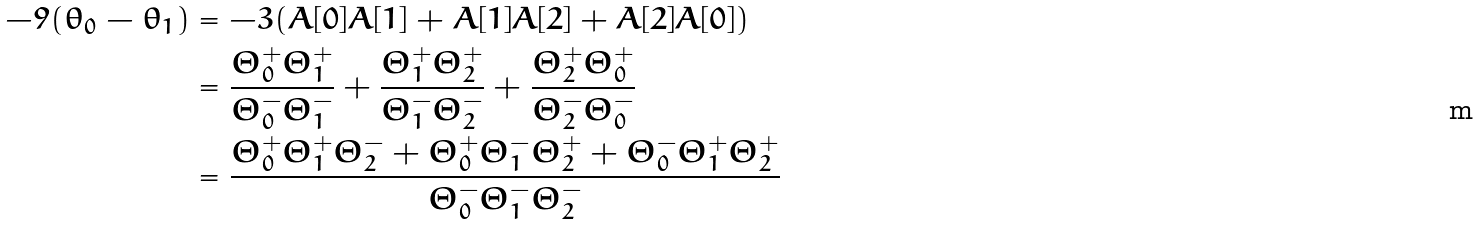<formula> <loc_0><loc_0><loc_500><loc_500>- 9 ( \theta _ { 0 } - \theta _ { 1 } ) & = - 3 ( A [ 0 ] A [ 1 ] + A [ 1 ] A [ 2 ] + A [ 2 ] A [ 0 ] ) \\ & = \frac { \Theta ^ { + } _ { 0 } \Theta ^ { + } _ { 1 } } { \Theta ^ { - } _ { 0 } \Theta ^ { - } _ { 1 } } + \frac { \Theta ^ { + } _ { 1 } \Theta ^ { + } _ { 2 } } { \Theta ^ { - } _ { 1 } \Theta ^ { - } _ { 2 } } + \frac { \Theta ^ { + } _ { 2 } \Theta ^ { + } _ { 0 } } { \Theta ^ { - } _ { 2 } \Theta ^ { - } _ { 0 } } \\ & = \frac { \Theta ^ { + } _ { 0 } \Theta ^ { + } _ { 1 } \Theta ^ { - } _ { 2 } + \Theta ^ { + } _ { 0 } \Theta ^ { - } _ { 1 } \Theta ^ { + } _ { 2 } + \Theta ^ { - } _ { 0 } \Theta ^ { + } _ { 1 } \Theta ^ { + } _ { 2 } } { \Theta ^ { - } _ { 0 } \Theta ^ { - } _ { 1 } \Theta ^ { - } _ { 2 } }</formula> 